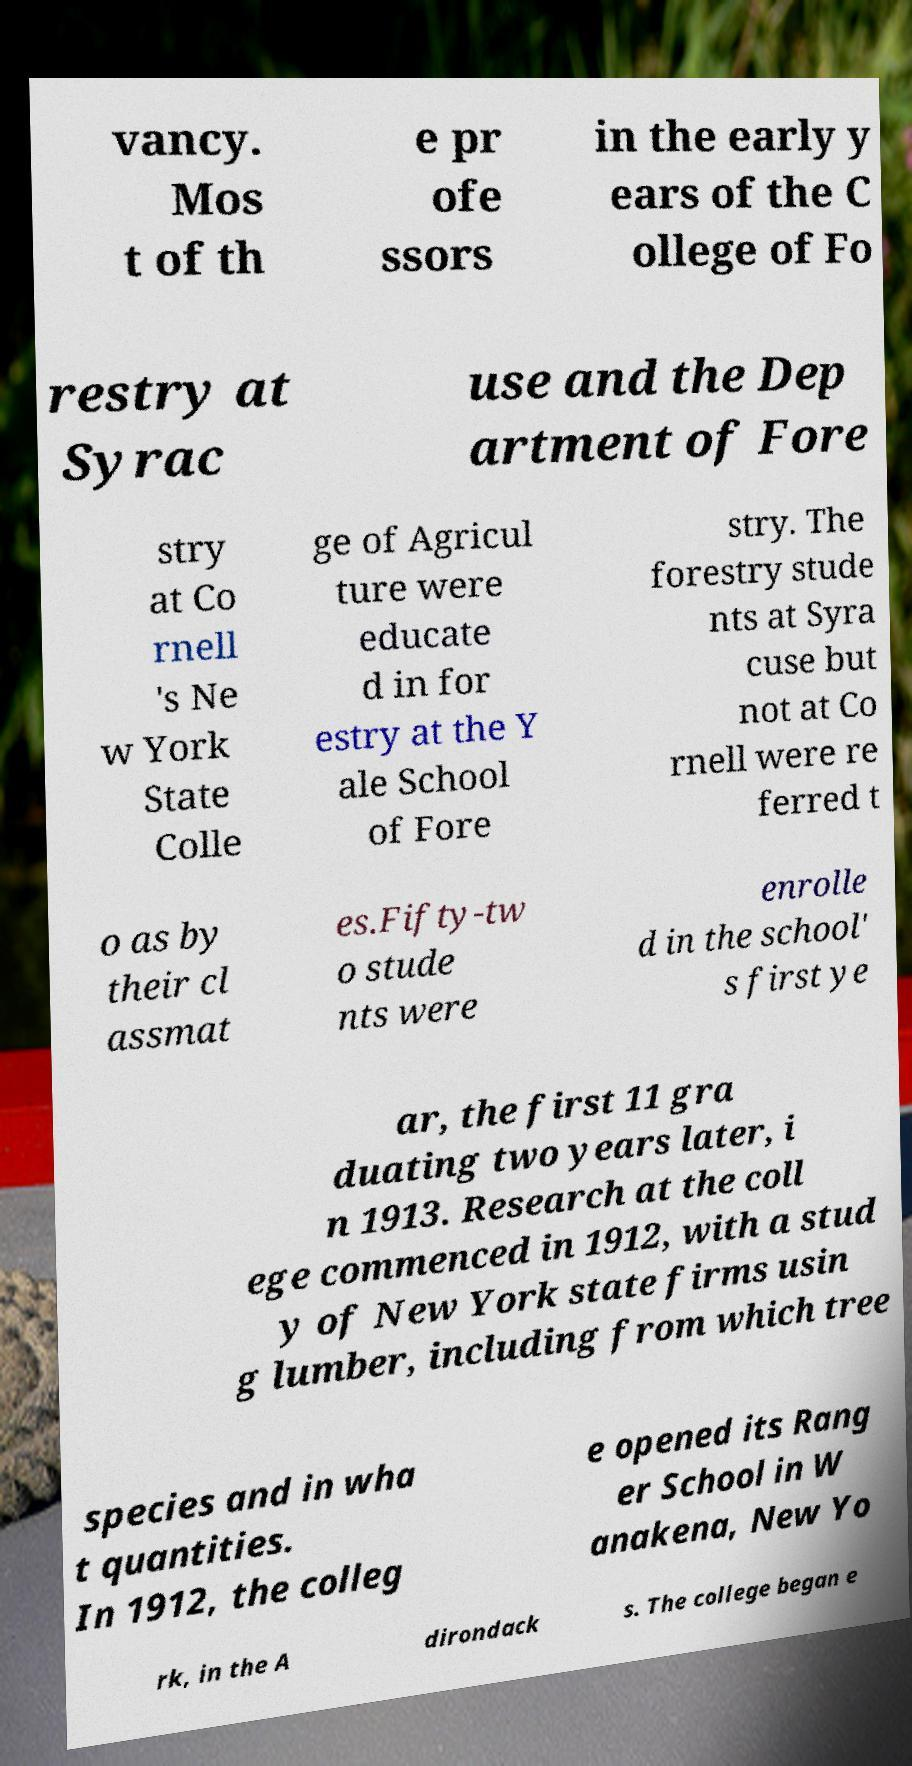What messages or text are displayed in this image? I need them in a readable, typed format. vancy. Mos t of th e pr ofe ssors in the early y ears of the C ollege of Fo restry at Syrac use and the Dep artment of Fore stry at Co rnell 's Ne w York State Colle ge of Agricul ture were educate d in for estry at the Y ale School of Fore stry. The forestry stude nts at Syra cuse but not at Co rnell were re ferred t o as by their cl assmat es.Fifty-tw o stude nts were enrolle d in the school' s first ye ar, the first 11 gra duating two years later, i n 1913. Research at the coll ege commenced in 1912, with a stud y of New York state firms usin g lumber, including from which tree species and in wha t quantities. In 1912, the colleg e opened its Rang er School in W anakena, New Yo rk, in the A dirondack s. The college began e 